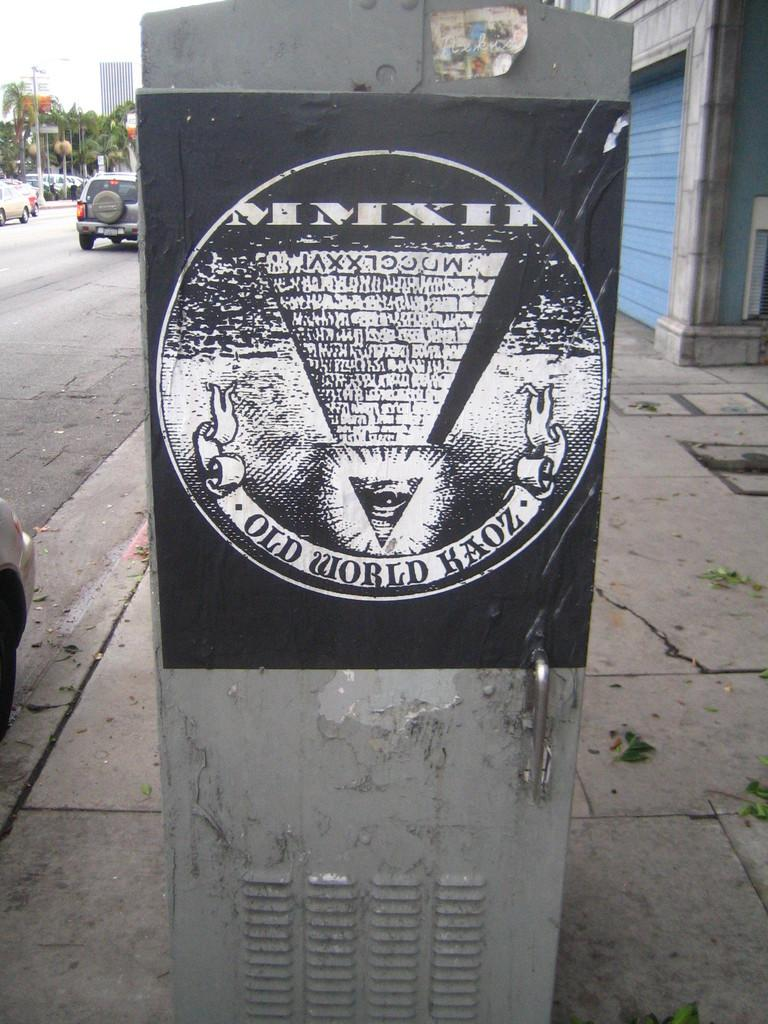<image>
Give a short and clear explanation of the subsequent image. Black sign which says "Old World Kaoz" on the bottom. 